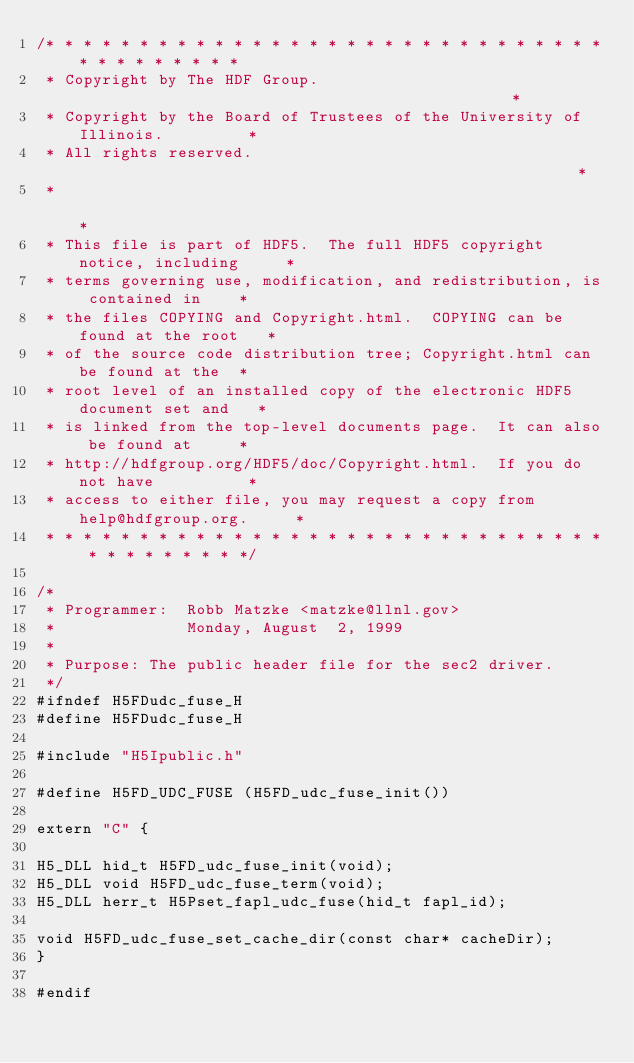Convert code to text. <code><loc_0><loc_0><loc_500><loc_500><_C_>/* * * * * * * * * * * * * * * * * * * * * * * * * * * * * * * * * * * * * * *
 * Copyright by The HDF Group.                                               *
 * Copyright by the Board of Trustees of the University of Illinois.         *
 * All rights reserved.                                                      *
 *                                                                           *
 * This file is part of HDF5.  The full HDF5 copyright notice, including     *
 * terms governing use, modification, and redistribution, is contained in    *
 * the files COPYING and Copyright.html.  COPYING can be found at the root   *
 * of the source code distribution tree; Copyright.html can be found at the  *
 * root level of an installed copy of the electronic HDF5 document set and   *
 * is linked from the top-level documents page.  It can also be found at     *
 * http://hdfgroup.org/HDF5/doc/Copyright.html.  If you do not have          *
 * access to either file, you may request a copy from help@hdfgroup.org.     *
 * * * * * * * * * * * * * * * * * * * * * * * * * * * * * * * * * * * * * * */

/*
 * Programmer:  Robb Matzke <matzke@llnl.gov>
 *              Monday, August  2, 1999
 *
 * Purpose:	The public header file for the sec2 driver.
 */
#ifndef H5FDudc_fuse_H
#define H5FDudc_fuse_H

#include "H5Ipublic.h"

#define H5FD_UDC_FUSE	(H5FD_udc_fuse_init())

extern "C" {

H5_DLL hid_t H5FD_udc_fuse_init(void);
H5_DLL void H5FD_udc_fuse_term(void);
H5_DLL herr_t H5Pset_fapl_udc_fuse(hid_t fapl_id);

void H5FD_udc_fuse_set_cache_dir(const char* cacheDir);
}

#endif
</code> 